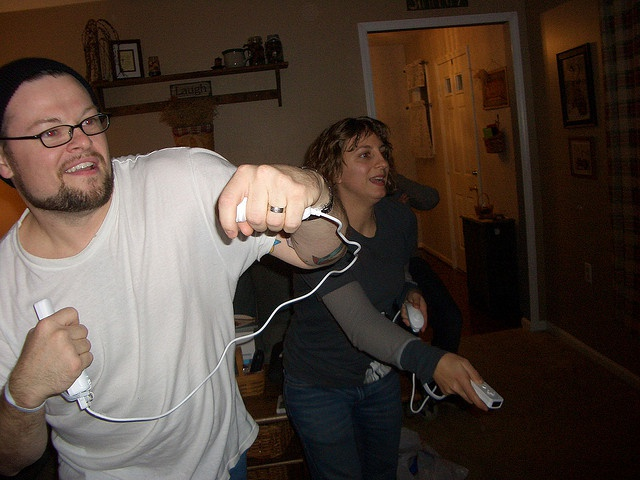Describe the objects in this image and their specific colors. I can see people in maroon, darkgray, lightgray, and gray tones, people in maroon, black, and gray tones, remote in maroon, lightgray, and darkgray tones, remote in maroon, gray, and black tones, and remote in maroon, gray, and black tones in this image. 